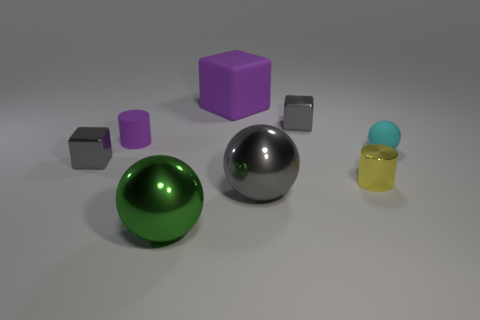There is a big thing behind the tiny purple object; does it have the same color as the small rubber cylinder?
Offer a terse response. Yes. What material is the small object that is both left of the purple matte cube and behind the small matte sphere?
Your answer should be very brief. Rubber. There is a large rubber thing; is its color the same as the tiny rubber thing that is on the left side of the gray shiny ball?
Your answer should be very brief. Yes. What number of other things are there of the same color as the large rubber thing?
Your answer should be compact. 1. What is the size of the cyan rubber thing that is the same shape as the big gray metal object?
Give a very brief answer. Small. How many things are either big metallic spheres that are left of the small cyan ball or gray metallic cubes right of the large purple cube?
Keep it short and to the point. 3. Are there fewer large blue metal balls than matte spheres?
Give a very brief answer. Yes. Does the rubber cube have the same size as the cylinder behind the tiny cyan thing?
Offer a very short reply. No. What number of metallic objects are either large gray objects or green balls?
Offer a terse response. 2. Is the number of large green metal objects greater than the number of tiny rubber things?
Provide a short and direct response. No. 